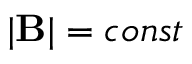<formula> <loc_0><loc_0><loc_500><loc_500>| { B } | = c o n s t</formula> 